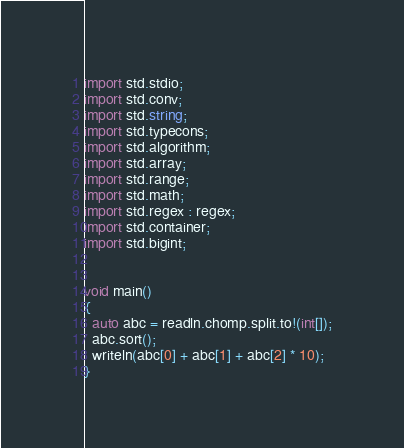Convert code to text. <code><loc_0><loc_0><loc_500><loc_500><_D_>import std.stdio;
import std.conv;
import std.string;
import std.typecons;
import std.algorithm;
import std.array;
import std.range;
import std.math;
import std.regex : regex;
import std.container;
import std.bigint;


void main()
{
  auto abc = readln.chomp.split.to!(int[]);
  abc.sort();
  writeln(abc[0] + abc[1] + abc[2] * 10);
}
</code> 